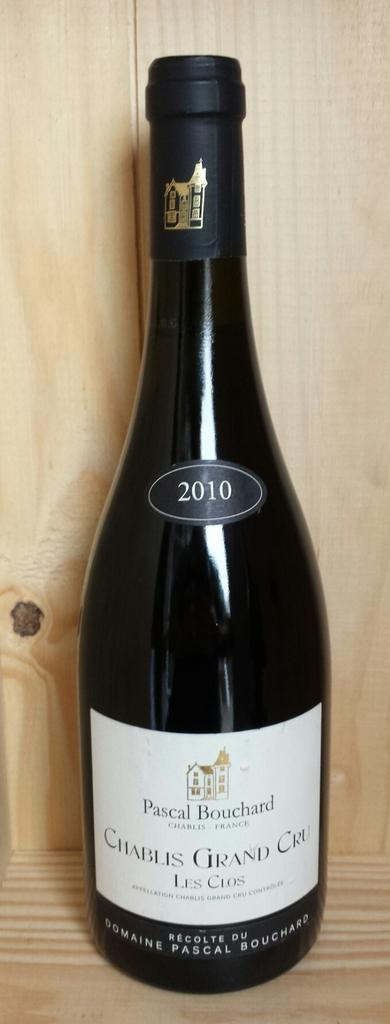<image>
Offer a succinct explanation of the picture presented. A single bottle of Chablis Grande Cru sits before a wood backdrop. 